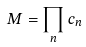Convert formula to latex. <formula><loc_0><loc_0><loc_500><loc_500>M = \prod _ { n } c _ { n }</formula> 